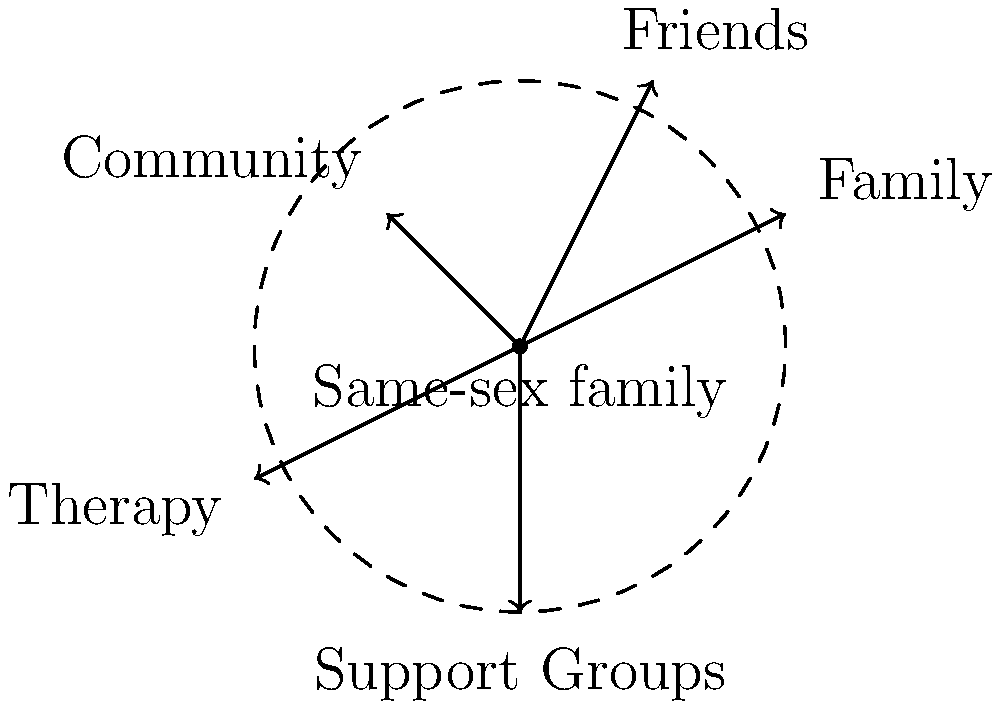In the force diagram representing the emotional support network for a same-sex family, which vector indicates the strongest support based on its magnitude, and what does this suggest about the role of that support system in the family's well-being? To answer this question, we need to follow these steps:

1. Identify the vectors in the diagram:
   - Family: (2,1)
   - Friends: (1,2)
   - Community: (-1,1)
   - Therapy: (-2,-1)
   - Support Groups: (0,-2)

2. Calculate the magnitude of each vector using the formula $\sqrt{x^2 + y^2}$:
   - Family: $\sqrt{2^2 + 1^2} = \sqrt{5} \approx 2.24$
   - Friends: $\sqrt{1^2 + 2^2} = \sqrt{5} \approx 2.24$
   - Community: $\sqrt{(-1)^2 + 1^2} = \sqrt{2} \approx 1.41$
   - Therapy: $\sqrt{(-2)^2 + (-1)^2} = \sqrt{5} \approx 2.24$
   - Support Groups: $\sqrt{0^2 + (-2)^2} = 2$

3. Compare the magnitudes:
   Family, Friends, and Therapy have the largest magnitude (2.24).

4. Interpret the result:
   The vectors for Family, Friends, and Therapy have equal magnitudes and are the strongest in the support network. This suggests that these three support systems play equally important roles in the family's well-being.

5. Consider the implications:
   For a social worker specializing in same-sex couples and their children, this information highlights the importance of fostering strong family bonds, encouraging supportive friendships, and providing access to quality therapy services. These three pillars of support appear to be crucial for the emotional well-being of same-sex families.
Answer: Family, Friends, and Therapy; equally strong and crucial support systems 